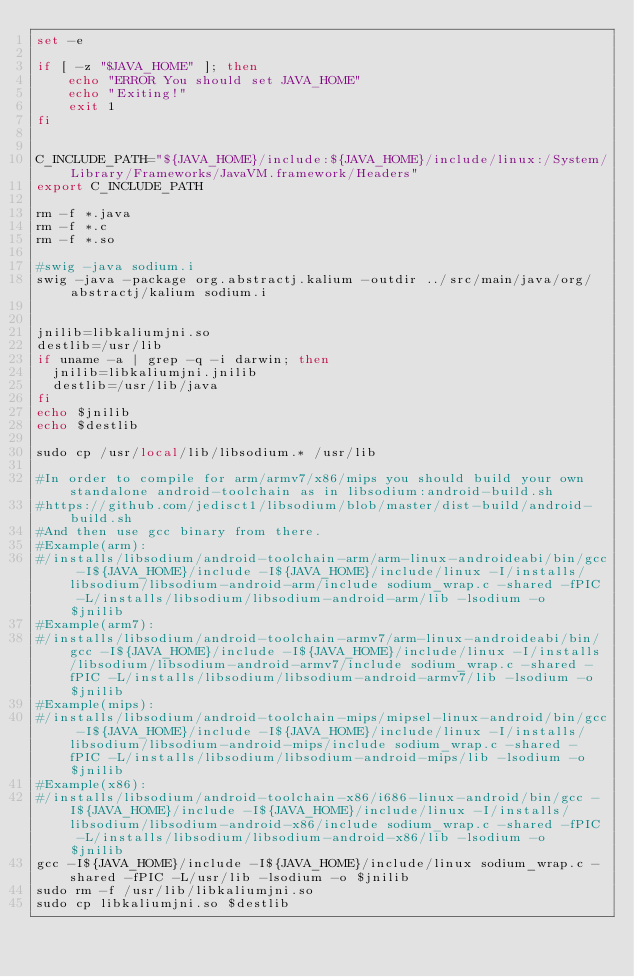<code> <loc_0><loc_0><loc_500><loc_500><_Bash_>set -e

if [ -z "$JAVA_HOME" ]; then
    echo "ERROR You should set JAVA_HOME"
    echo "Exiting!"
    exit 1
fi


C_INCLUDE_PATH="${JAVA_HOME}/include:${JAVA_HOME}/include/linux:/System/Library/Frameworks/JavaVM.framework/Headers"
export C_INCLUDE_PATH

rm -f *.java
rm -f *.c
rm -f *.so

#swig -java sodium.i
swig -java -package org.abstractj.kalium -outdir ../src/main/java/org/abstractj/kalium sodium.i


jnilib=libkaliumjni.so
destlib=/usr/lib
if uname -a | grep -q -i darwin; then
  jnilib=libkaliumjni.jnilib
  destlib=/usr/lib/java
fi
echo $jnilib
echo $destlib

sudo cp /usr/local/lib/libsodium.* /usr/lib

#In order to compile for arm/armv7/x86/mips you should build your own standalone android-toolchain as in libsodium:android-build.sh
#https://github.com/jedisct1/libsodium/blob/master/dist-build/android-build.sh
#And then use gcc binary from there. 
#Example(arm):
#/installs/libsodium/android-toolchain-arm/arm-linux-androideabi/bin/gcc -I${JAVA_HOME}/include -I${JAVA_HOME}/include/linux -I/installs/libsodium/libsodium-android-arm/include sodium_wrap.c -shared -fPIC -L/installs/libsodium/libsodium-android-arm/lib -lsodium -o $jnilib
#Example(arm7):
#/installs/libsodium/android-toolchain-armv7/arm-linux-androideabi/bin/gcc -I${JAVA_HOME}/include -I${JAVA_HOME}/include/linux -I/installs/libsodium/libsodium-android-armv7/include sodium_wrap.c -shared -fPIC -L/installs/libsodium/libsodium-android-armv7/lib -lsodium -o $jnilib
#Example(mips):
#/installs/libsodium/android-toolchain-mips/mipsel-linux-android/bin/gcc -I${JAVA_HOME}/include -I${JAVA_HOME}/include/linux -I/installs/libsodium/libsodium-android-mips/include sodium_wrap.c -shared -fPIC -L/installs/libsodium/libsodium-android-mips/lib -lsodium -o $jnilib
#Example(x86):
#/installs/libsodium/android-toolchain-x86/i686-linux-android/bin/gcc -I${JAVA_HOME}/include -I${JAVA_HOME}/include/linux -I/installs/libsodium/libsodium-android-x86/include sodium_wrap.c -shared -fPIC -L/installs/libsodium/libsodium-android-x86/lib -lsodium -o $jnilib
gcc -I${JAVA_HOME}/include -I${JAVA_HOME}/include/linux sodium_wrap.c -shared -fPIC -L/usr/lib -lsodium -o $jnilib
sudo rm -f /usr/lib/libkaliumjni.so 
sudo cp libkaliumjni.so $destlib

</code> 